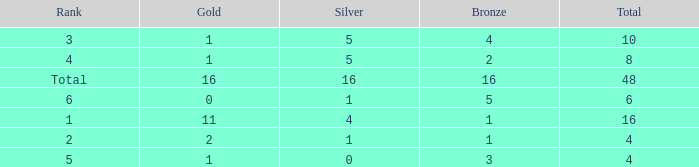How many gold are a rank 1 and larger than 16? 0.0. 